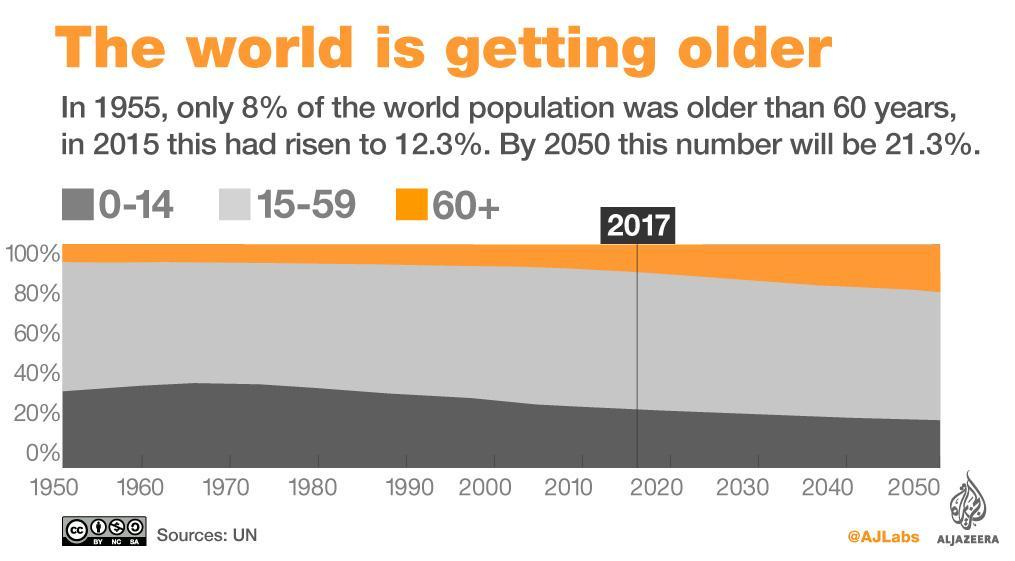The population of which age group is seen to be increasing by 2050?
Answer the question with a short phrase. 60+ The population of which age group is seen to be decreasing by 2050? 0-14 